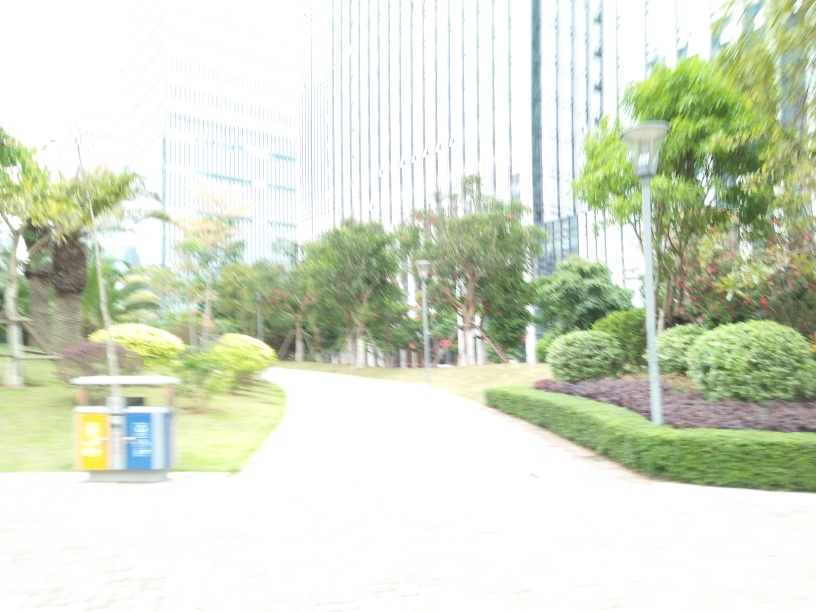Can you describe the general atmosphere or mood of this place? Despite the image's overexposure, there's a sense of peacefulness in the scene, with lush greenery and a clear pathway inviting a leisurely stroll, possibly in a park or garden area within an urban environment. 